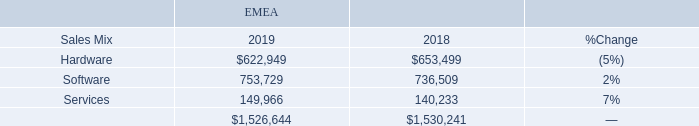Our net sales by offering category for EMEA for 2019 and 2018, were as follows (dollars in thousands):
Net sales in EMEA remained flat (increased 5% excluding the effects of fluctuating foreign currency exchange rates), or down $3.6 million, in 2019 compared to 2018. Net sales of hardware declined 5%, year to year, while net sales of software and services were up 2% and 7%, respectively, year over year. The changes were the result of the following:
• Lower volume of net sales of networking solutions, partially offset by higher volume of net sales of devices, to large enterprise and public sector clients in hardware net sales. • Higher volume of software net sales to large enterprise and public sector clients.
• Higher volume of net sales of cloud solution offerings and increased software referral fees that are recorded on a net sales recognition basis. In addition, there was an increase in the volume of Insight delivered services.
What was the net sales of hardware in 2019 and 2018 respectively?
Answer scale should be: thousand. $622,949, $653,499. What was the net sales of software in 2019 and 2018 respectively?
Answer scale should be: thousand. 753,729, 736,509. What was the net sales of services in 2019 and 2018 respectively?
Answer scale should be: thousand. 149,966, 140,233. What is the change in Sales Mix of Hardware between 2018 and 2019?
Answer scale should be: thousand. 622,949-653,499
Answer: -30550. What is the change in Sales Mix of Software between 2018 and 2019?
Answer scale should be: thousand. 753,729-736,509
Answer: 17220. What is the average Sales Mix of Hardware for 2018 and 2019?
Answer scale should be: thousand. (622,949+653,499) / 2
Answer: 638224. 